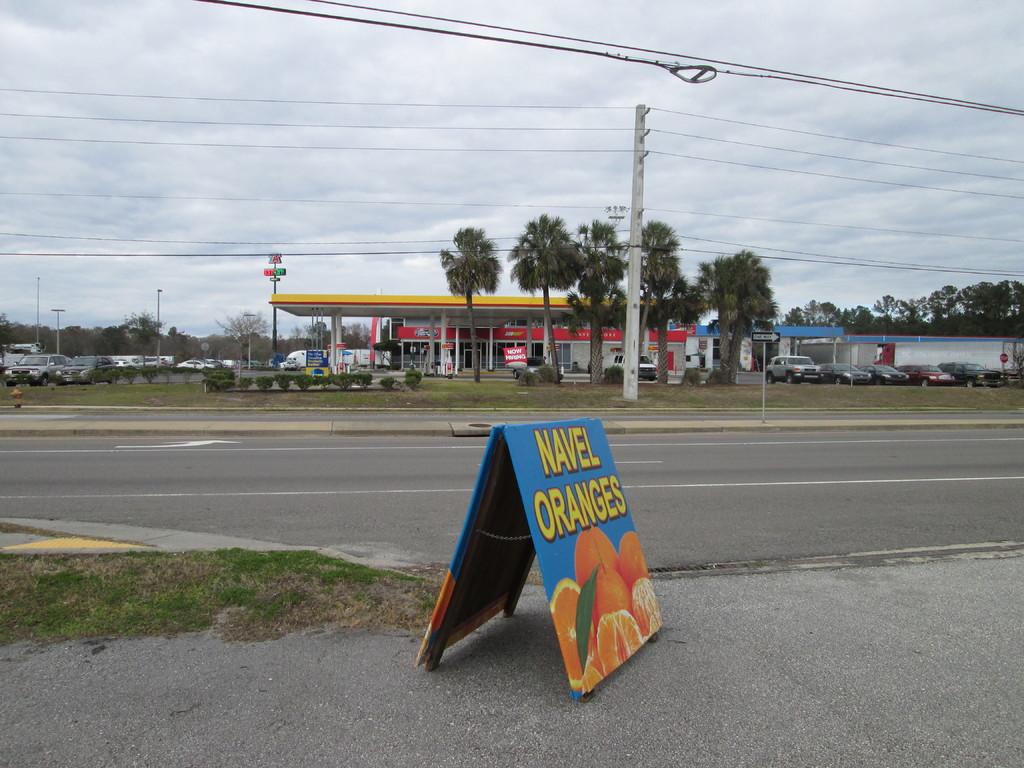What type of oranges are advertised here?
Your response must be concise. Navel. What does the street sign in the background say?
Provide a short and direct response. One way. 